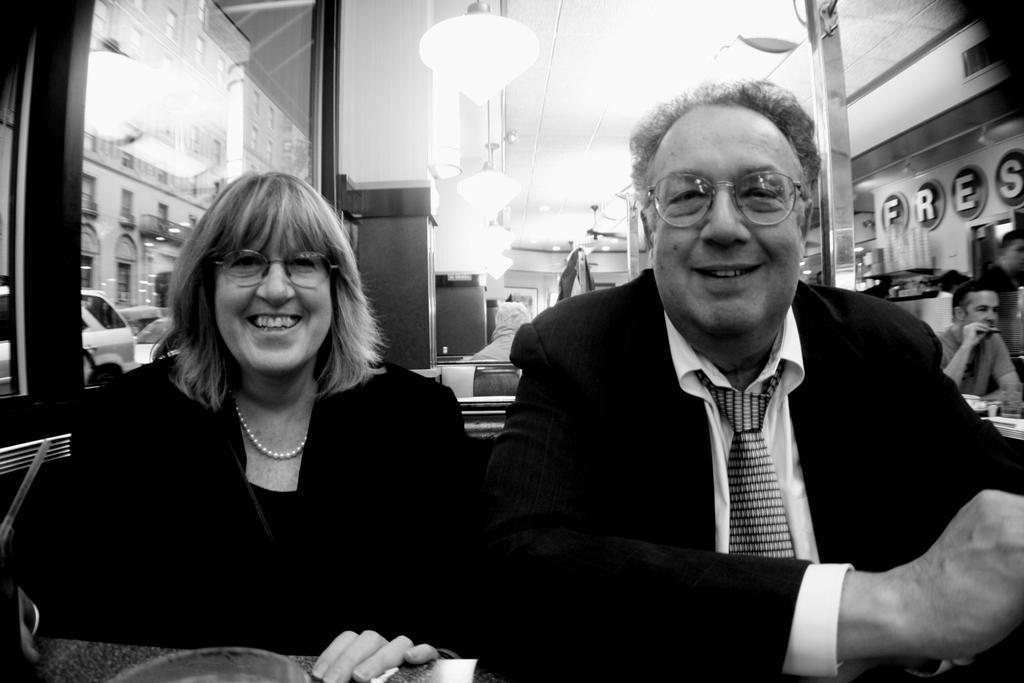Can you describe this image briefly? This is a black and white image. There are two persons in this image. One is man, another one is a woman. There are lights at the top. 